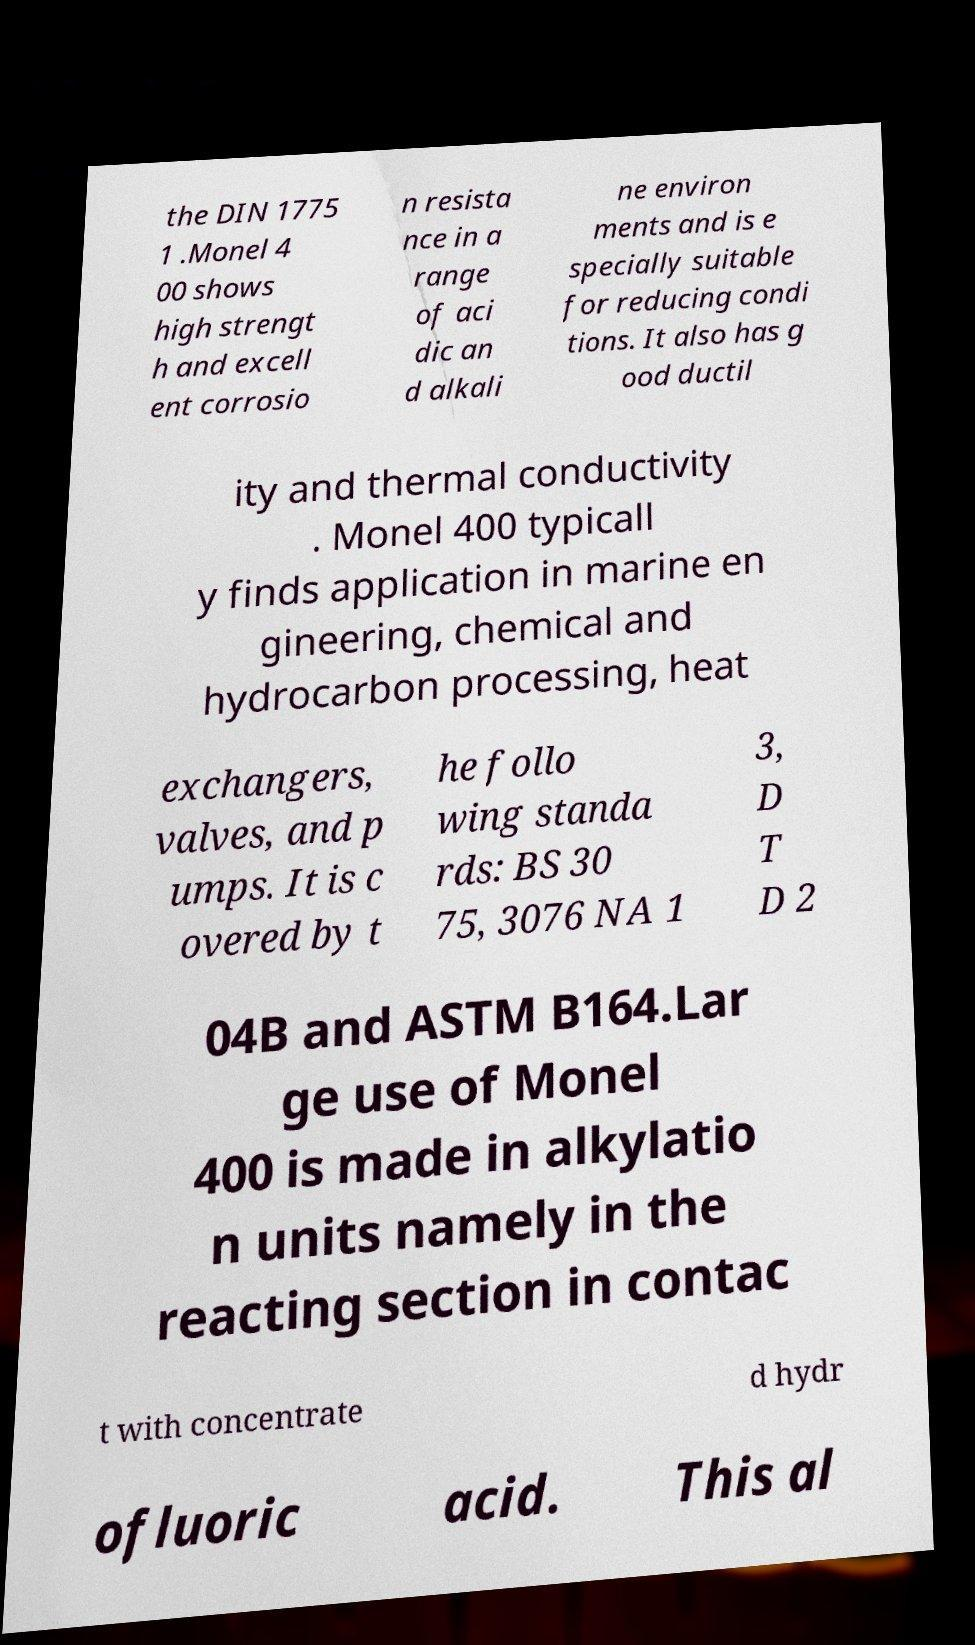Could you extract and type out the text from this image? the DIN 1775 1 .Monel 4 00 shows high strengt h and excell ent corrosio n resista nce in a range of aci dic an d alkali ne environ ments and is e specially suitable for reducing condi tions. It also has g ood ductil ity and thermal conductivity . Monel 400 typicall y finds application in marine en gineering, chemical and hydrocarbon processing, heat exchangers, valves, and p umps. It is c overed by t he follo wing standa rds: BS 30 75, 3076 NA 1 3, D T D 2 04B and ASTM B164.Lar ge use of Monel 400 is made in alkylatio n units namely in the reacting section in contac t with concentrate d hydr ofluoric acid. This al 